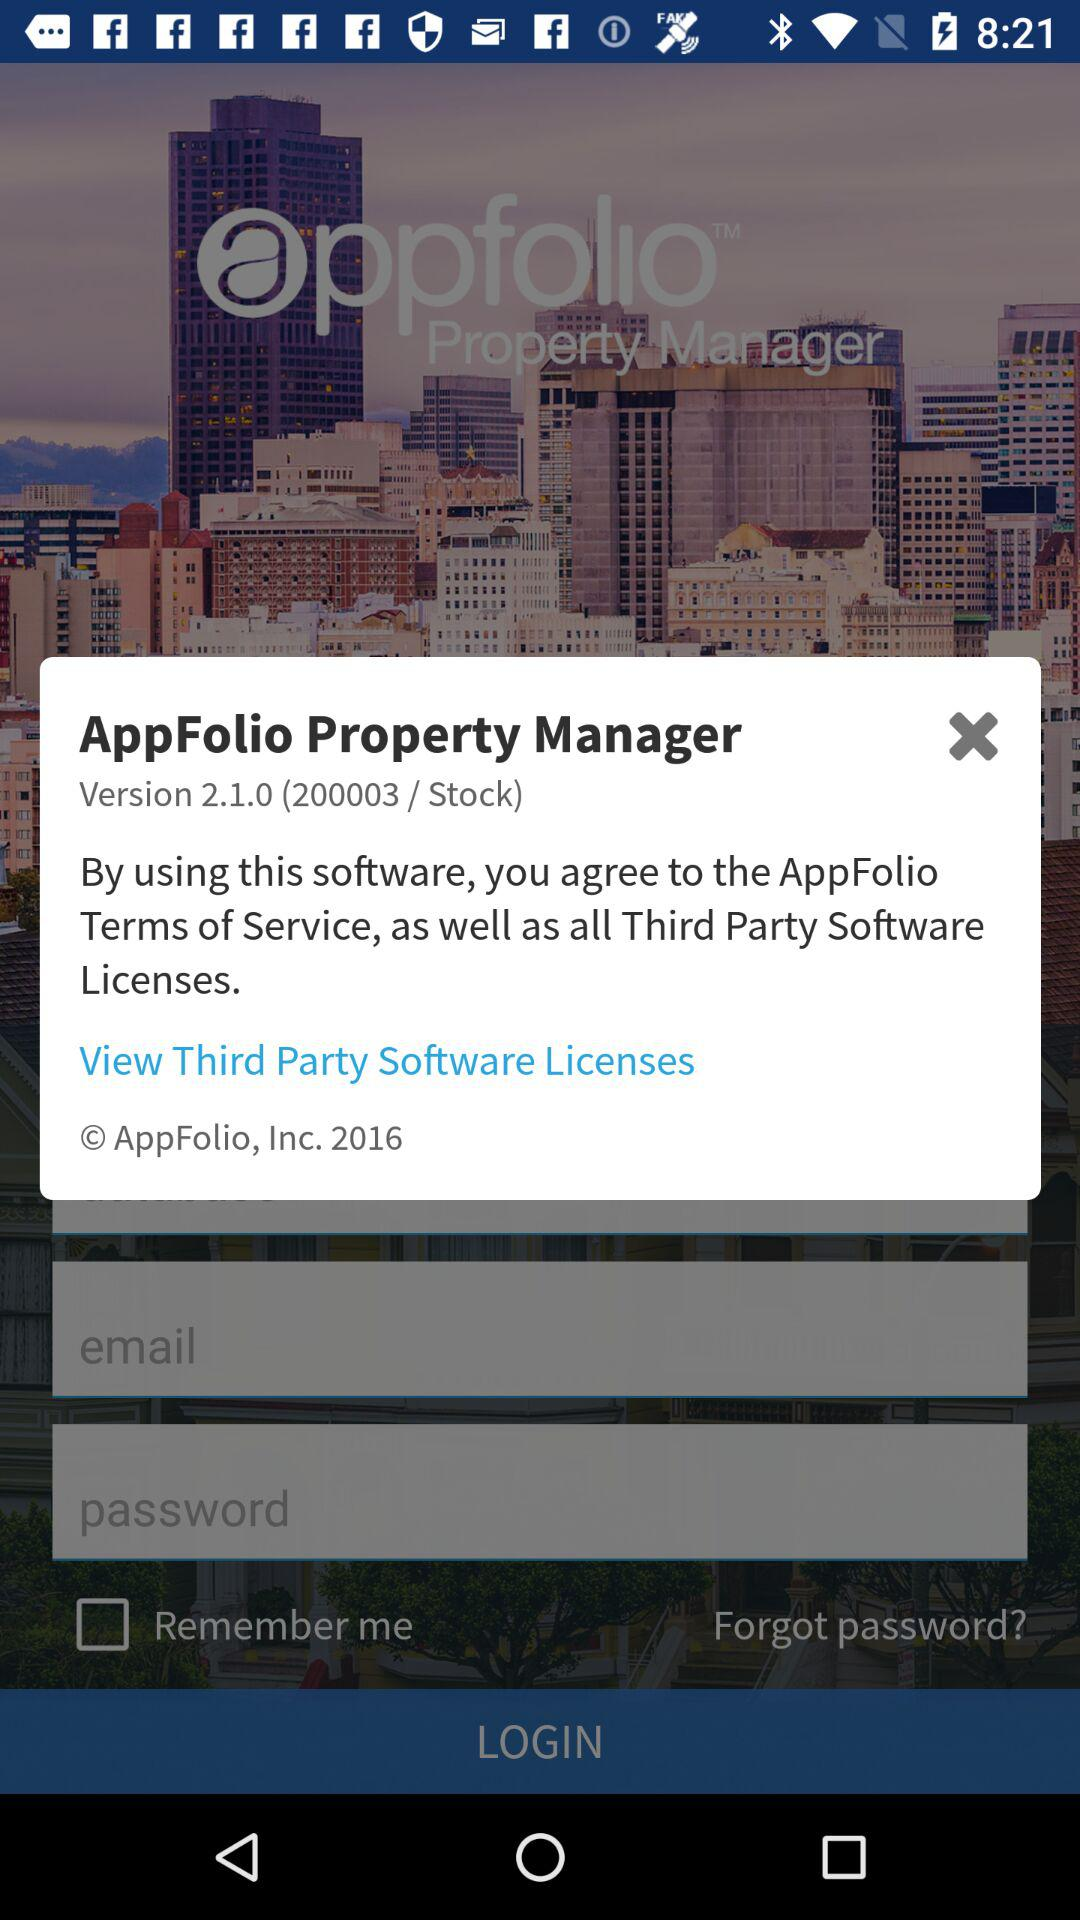What is the version? The version is 2.1.0. 